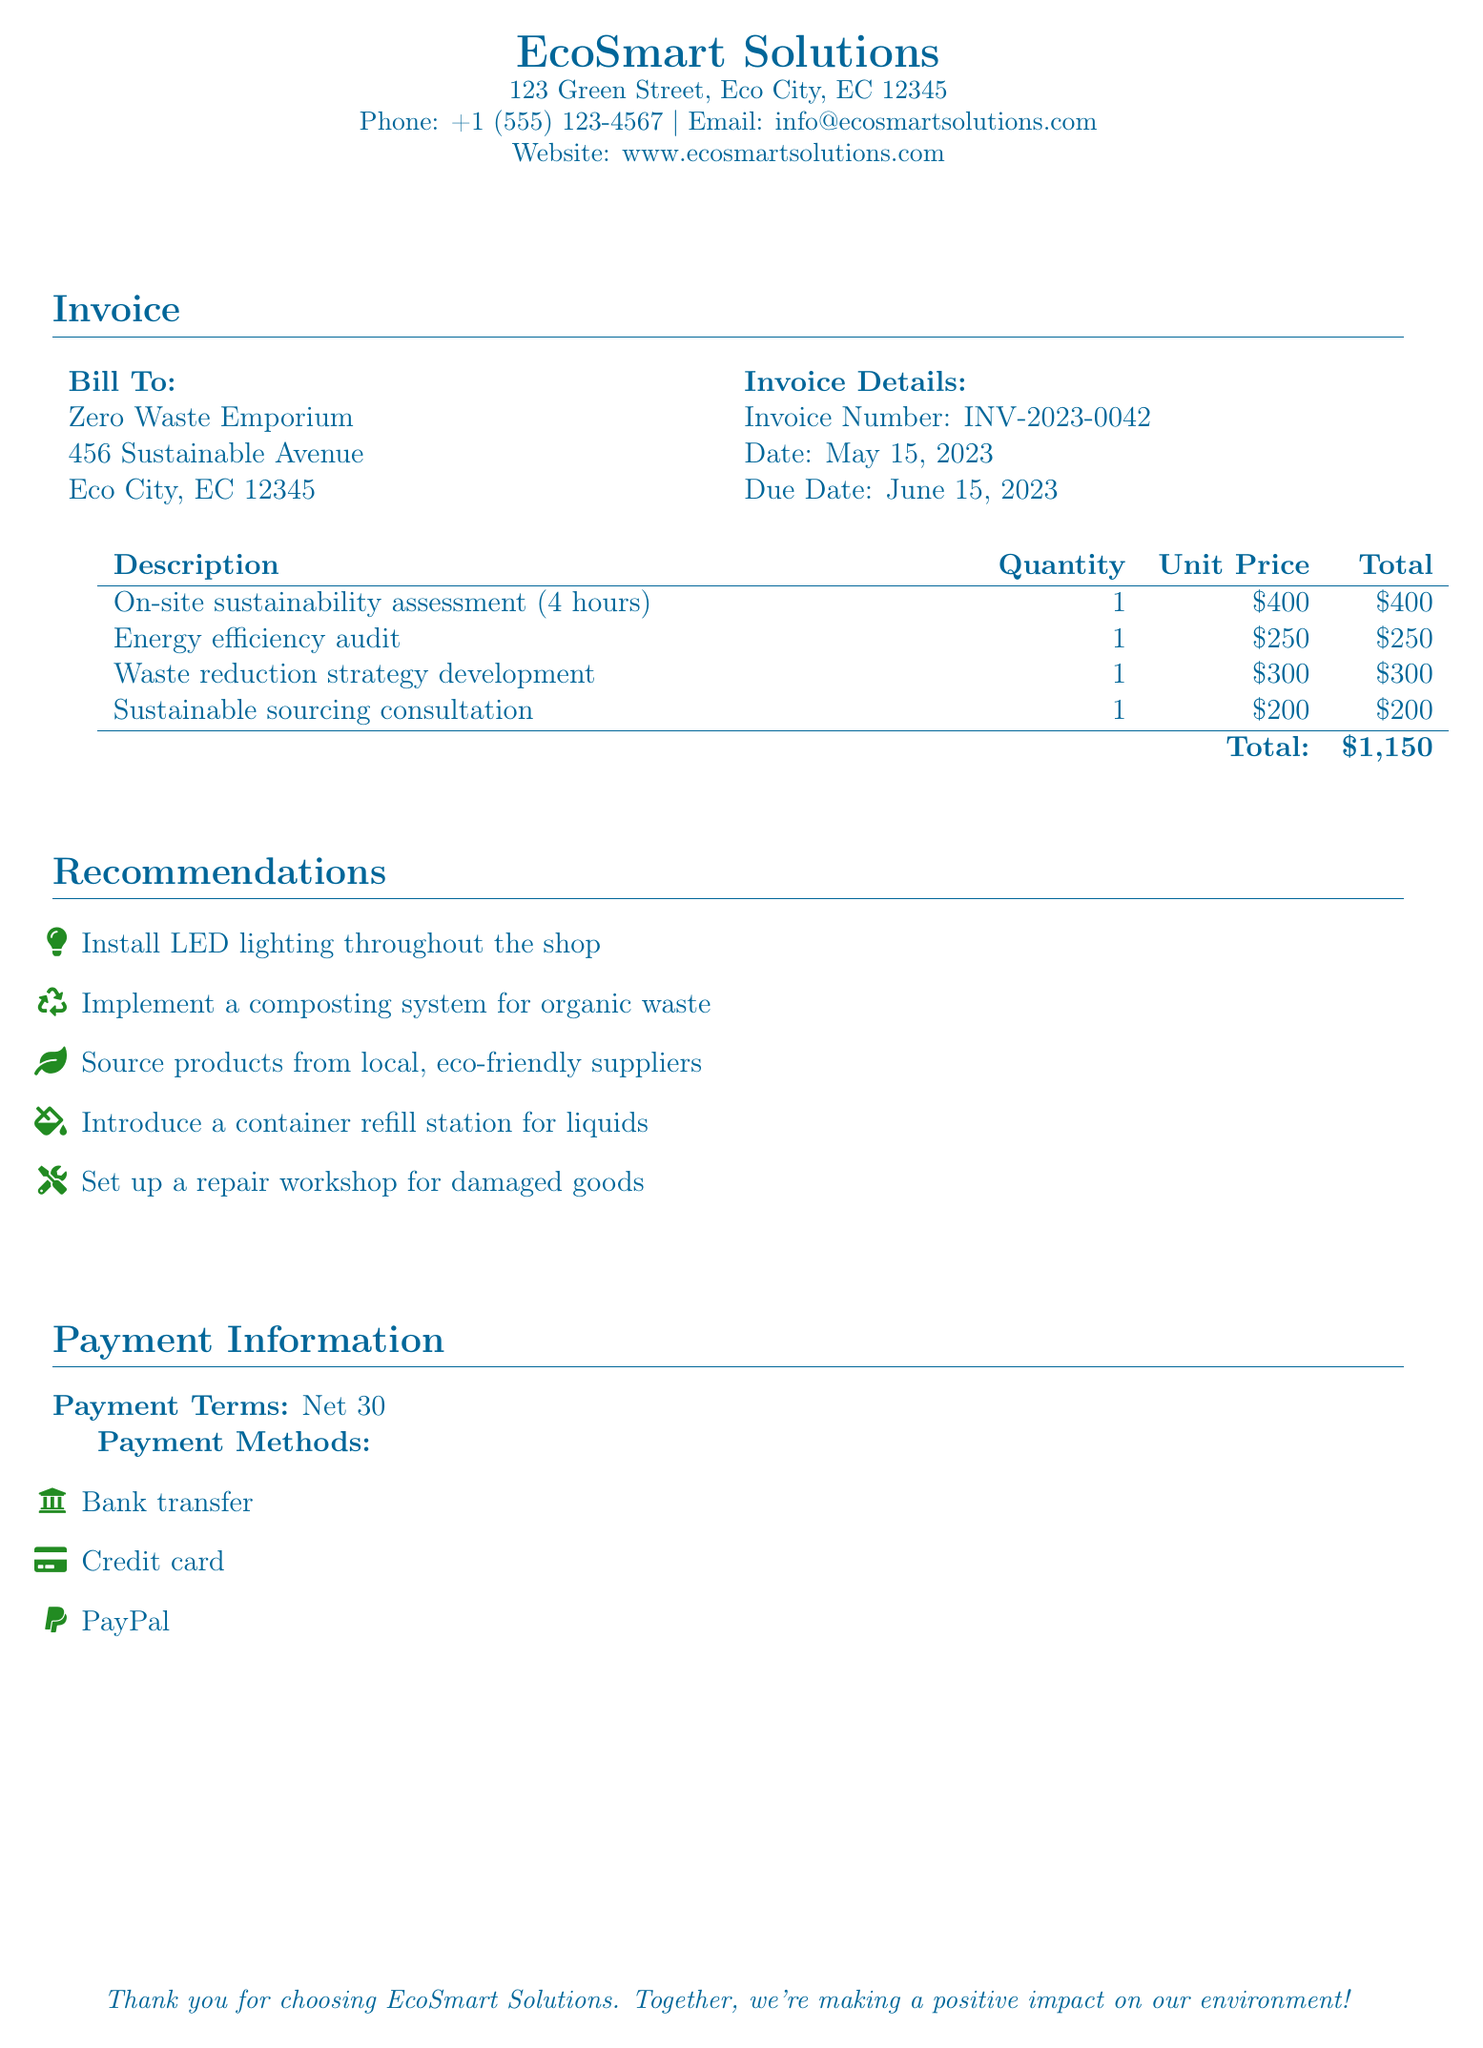What is the invoice number? The invoice number is listed in the document, which is INV-2023-0042.
Answer: INV-2023-0042 What is the total amount due? The total amount due is calculated at the end of the invoice, which states: Total: $1,150.
Answer: $1,150 When is the due date for the invoice? The due date can be found in the invoice details, which is June 15, 2023.
Answer: June 15, 2023 What type of service was performed for four hours? The service performed for four hours is the on-site sustainability assessment.
Answer: on-site sustainability assessment How many recommendations are listed for improving environmental impact? The document lists five recommendations in the recommendations section.
Answer: five What is the payment term? The payment term is specified as Net 30.
Answer: Net 30 What is one payment method mentioned? The document mentions several payment methods; one of them is PayPal.
Answer: PayPal What type of audit was included in the consultation services? The type of audit included is an energy efficiency audit.
Answer: energy efficiency audit What item involves a container refill station? The introduction of a container refill station for liquids is noted among the recommendations.
Answer: container refill station for liquids 